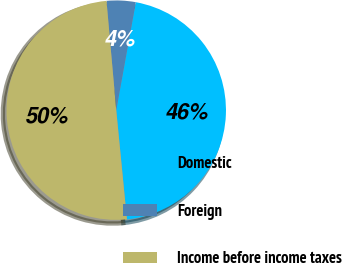Convert chart. <chart><loc_0><loc_0><loc_500><loc_500><pie_chart><fcel>Domestic<fcel>Foreign<fcel>Income before income taxes<nl><fcel>45.59%<fcel>4.27%<fcel>50.14%<nl></chart> 